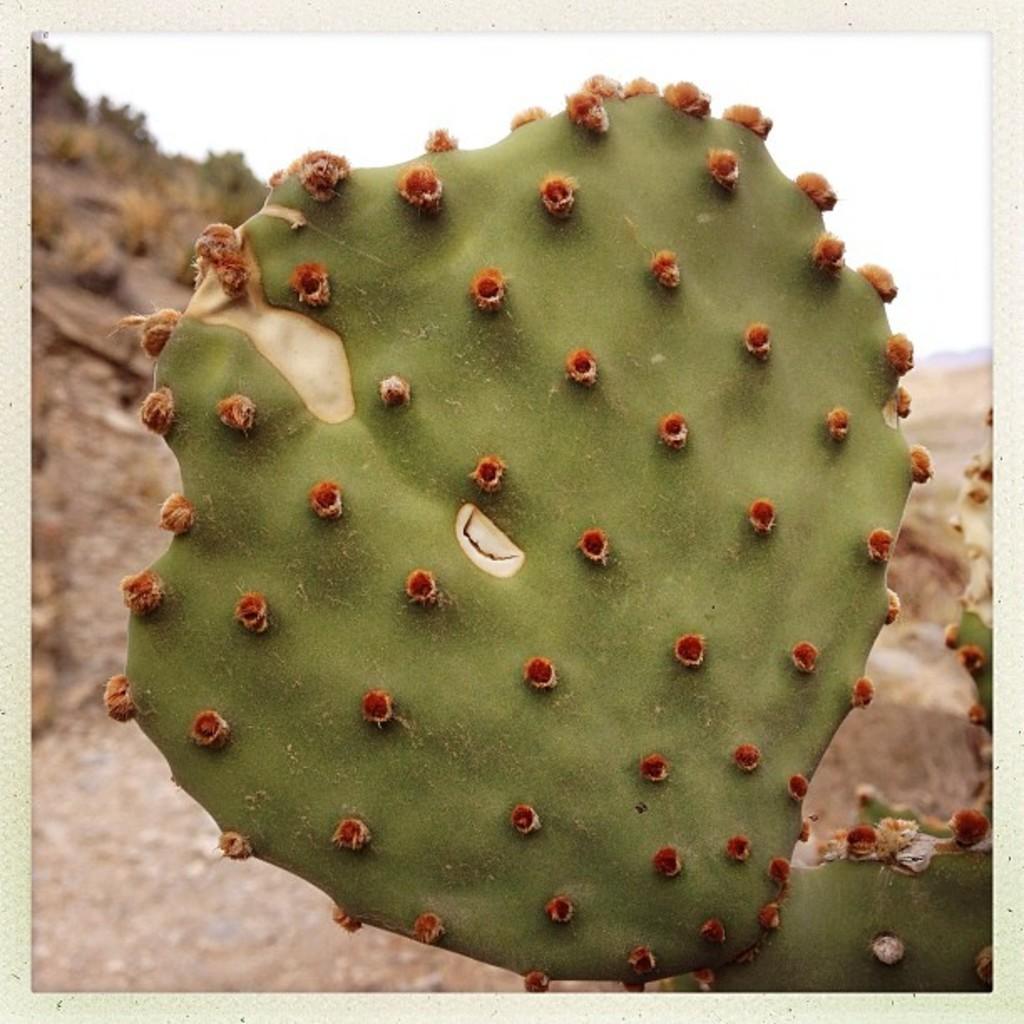In one or two sentences, can you explain what this image depicts? The picture consists of a cactus plant. In the background there are soil, stones, shrubs and hills. 